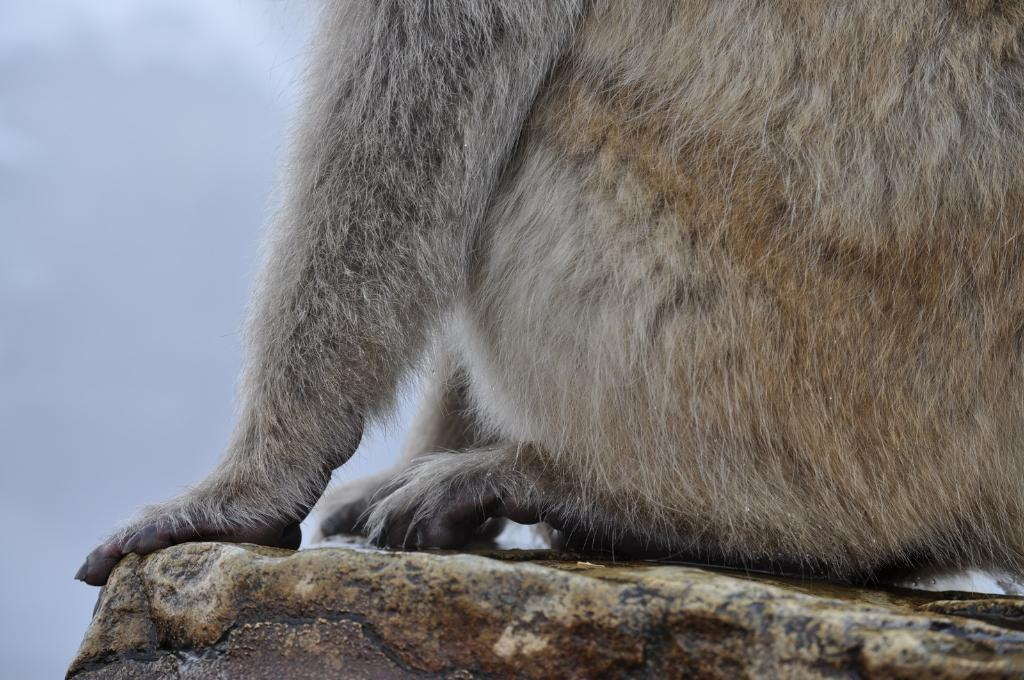What type of animal is present in the image? There is an animal in the image. Can you describe the animal's position or posture? The animal is sitting on rocks. What can be seen in the background of the image? The sky is visible in the background of the image. Is the animal kicking a screw in the image? There is no screw or indication of kicking in the image; it features an animal sitting on rocks with the sky visible in the background. 